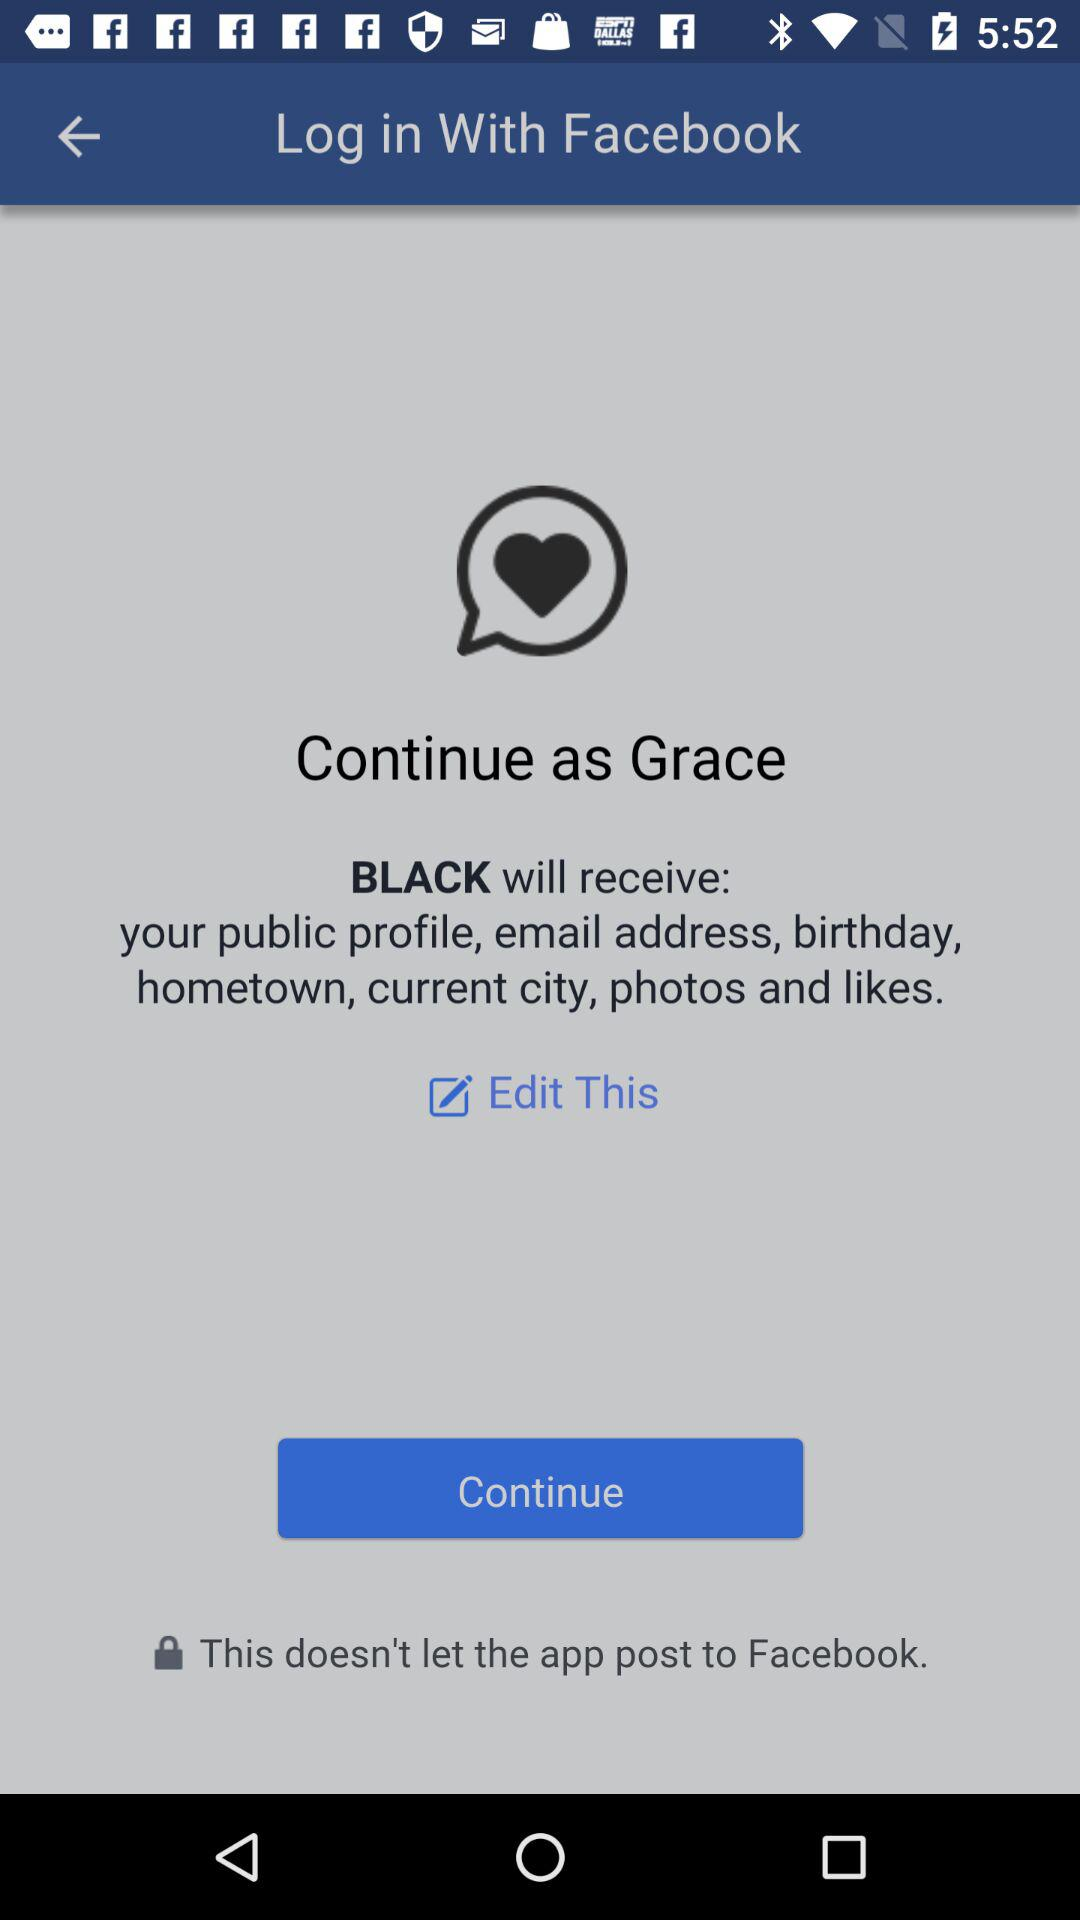What application is asking for permission? The application asking for permission is "BLACK". 